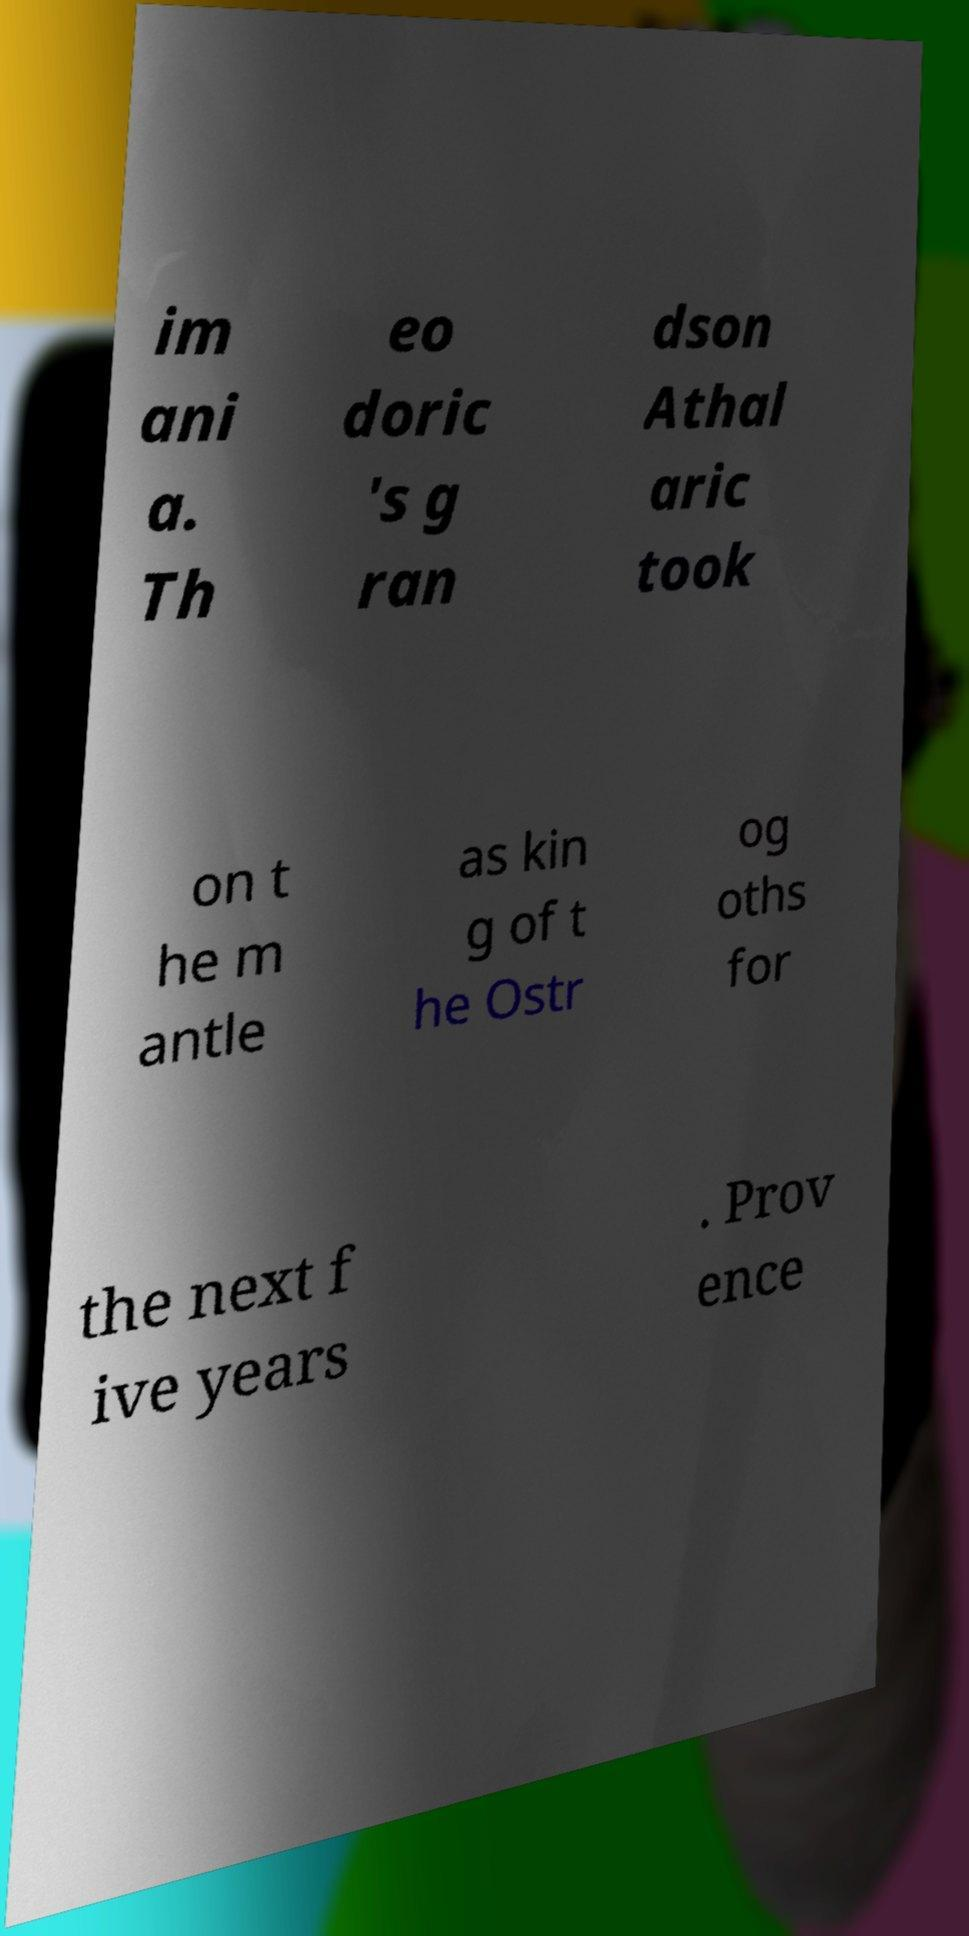Can you read and provide the text displayed in the image?This photo seems to have some interesting text. Can you extract and type it out for me? im ani a. Th eo doric 's g ran dson Athal aric took on t he m antle as kin g of t he Ostr og oths for the next f ive years . Prov ence 